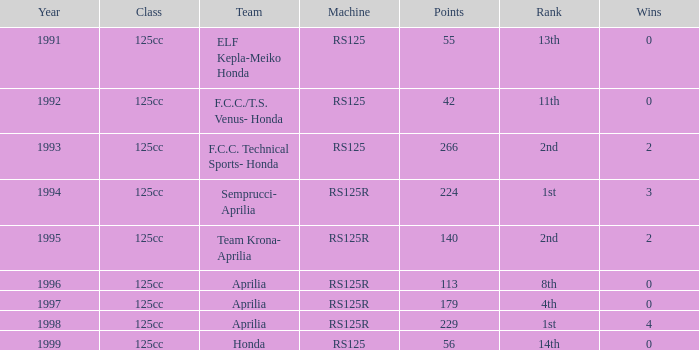Which class had a machine of RS125R, points over 113, and a rank of 4th? 125cc. Could you parse the entire table as a dict? {'header': ['Year', 'Class', 'Team', 'Machine', 'Points', 'Rank', 'Wins'], 'rows': [['1991', '125cc', 'ELF Kepla-Meiko Honda', 'RS125', '55', '13th', '0'], ['1992', '125cc', 'F.C.C./T.S. Venus- Honda', 'RS125', '42', '11th', '0'], ['1993', '125cc', 'F.C.C. Technical Sports- Honda', 'RS125', '266', '2nd', '2'], ['1994', '125cc', 'Semprucci- Aprilia', 'RS125R', '224', '1st', '3'], ['1995', '125cc', 'Team Krona- Aprilia', 'RS125R', '140', '2nd', '2'], ['1996', '125cc', 'Aprilia', 'RS125R', '113', '8th', '0'], ['1997', '125cc', 'Aprilia', 'RS125R', '179', '4th', '0'], ['1998', '125cc', 'Aprilia', 'RS125R', '229', '1st', '4'], ['1999', '125cc', 'Honda', 'RS125', '56', '14th', '0']]} 